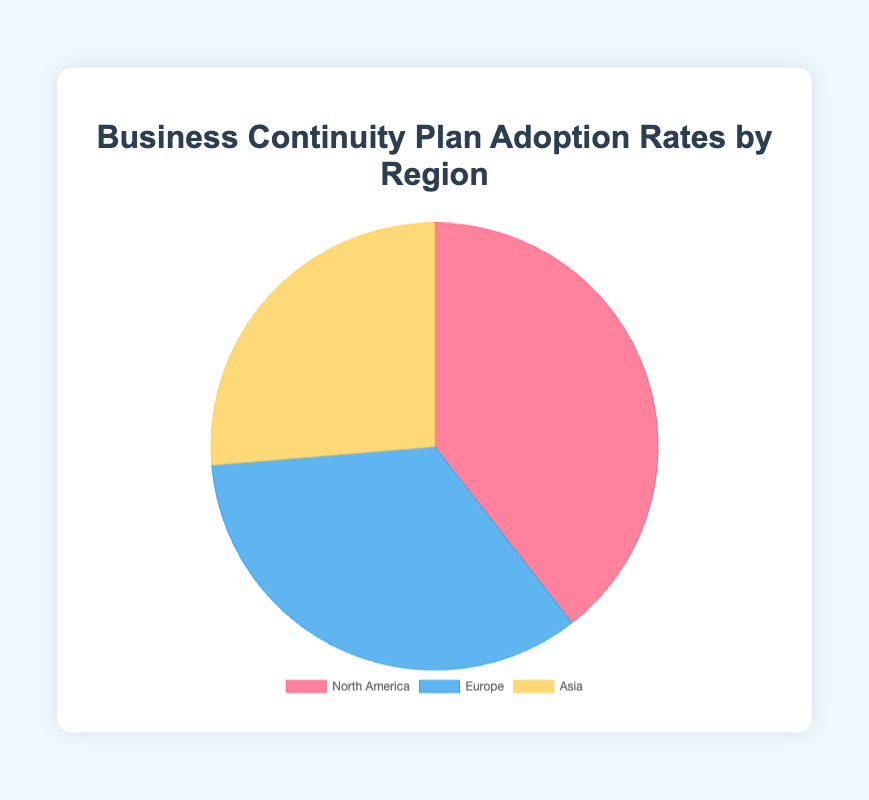What is the adoption rate of business continuity plans in North America? The figure shows different adoption rates for each region, with North America having a specific portion of the pie chart. The label on the North American section of the pie chart indicates its adoption rate.
Answer: 75% Which region has the lowest adoption rate of business continuity plans? The pie chart shows three regions with different adoption rates. By comparing the sizes or labels of the sections, we see that Asia has the smallest portion.
Answer: Asia What is the difference in adoption rates between Europe and Asia? To find the difference, subtract Asia's adoption rate from Europe's. According to the chart, Europe has an adoption rate of 65%, and Asia has 50%. The difference is 65% - 50%.
Answer: 15% Which regions have an adoption rate below 70%? The adoption rates for all regions are labeled on the pie chart. By checking which are below 70%, we identify Europe and Asia.
Answer: Europe and Asia What is the combined adoption rate of Europe and Asia? To find the combined adoption rate, add the adoption rates of Europe and Asia. Europe is 65% and Asia is 50%. The sum is 65% + 50%.
Answer: 115% Which region is represented by the blue color on the pie chart? By checking the legend or visual markers on the pie chart, we see which section is colored blue and its corresponding label shows the region.
Answer: Europe How much higher is North America's adoption rate compared to Asia's? To determine how much higher North America's rate is, subtract Asia's adoption rate from North America's. North America has 75%, and Asia has 50%, so 75% - 50%.
Answer: 25% In what range do all the regions' adoption rates fall? By observing the labeled percentages for each region on the pie chart, we see that the rates range from the lowest (Asia at 50%) to the highest (North America at 75%).
Answer: 50%-75% What is the average adoption rate of business continuity plans across all regions? Sum the adoption rates of all regions and divide by the number of regions. (75% + 65% + 50%) / 3 regions = 63.33%.
Answer: 63.33% 